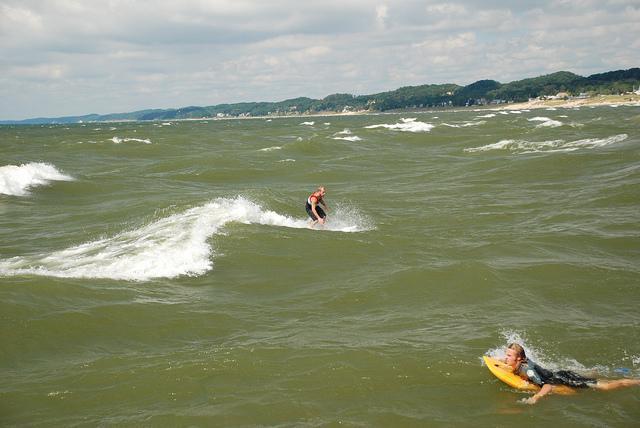How many surfers do you see?
Give a very brief answer. 2. How many surfers are there?
Give a very brief answer. 2. 